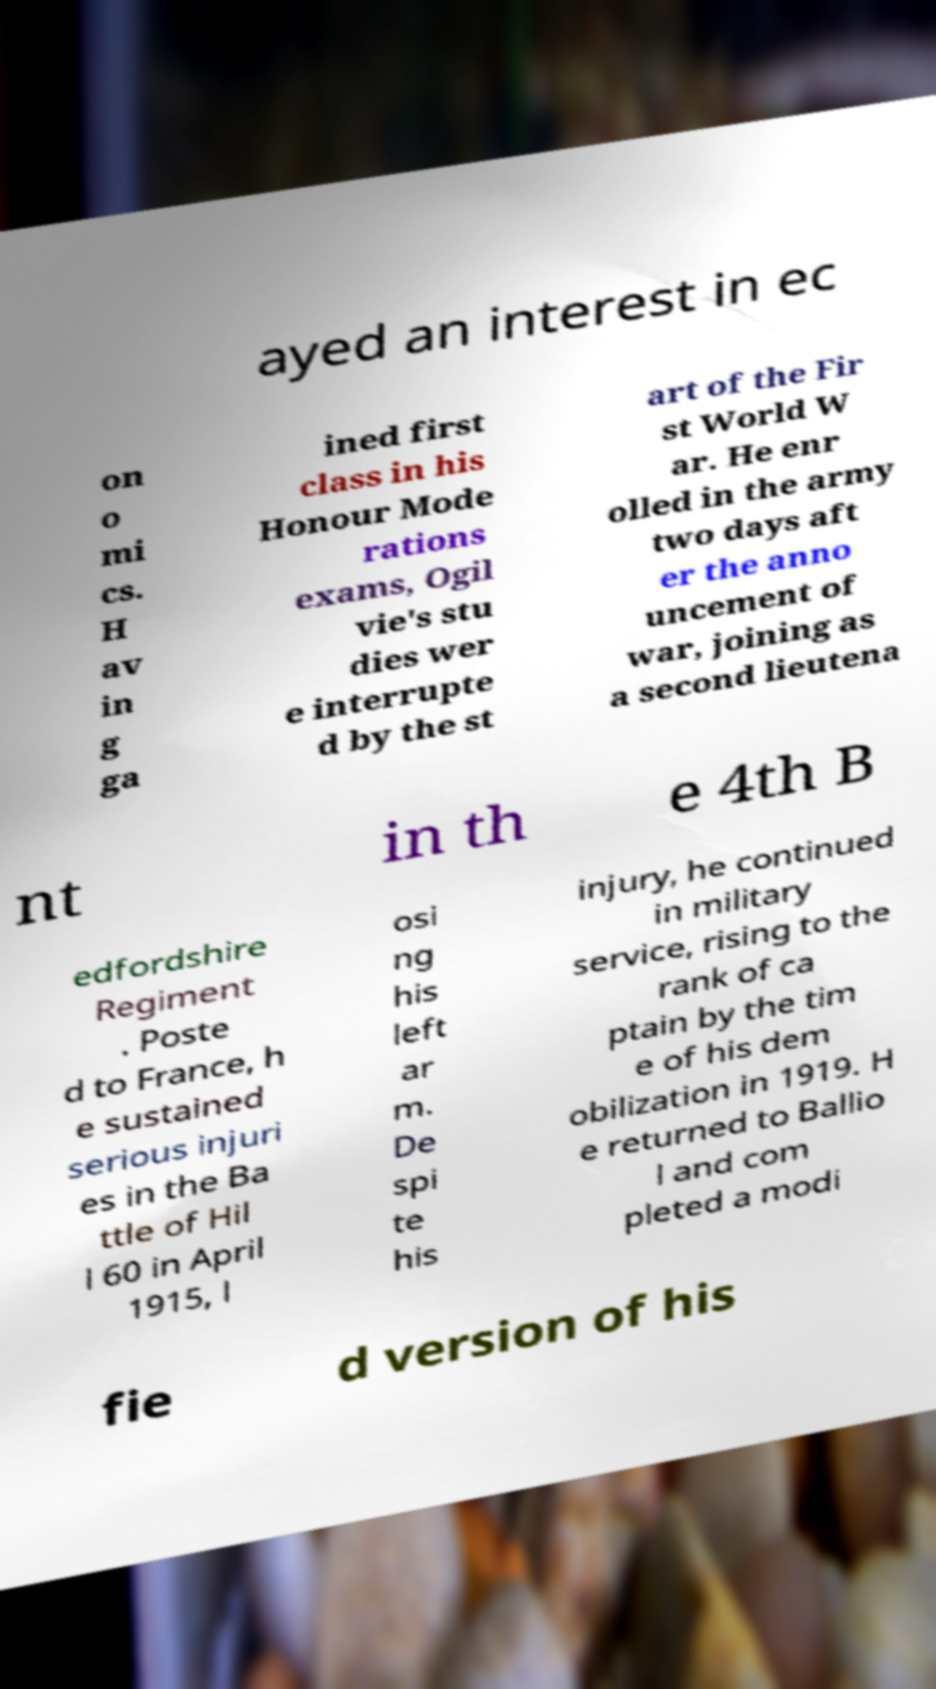Could you extract and type out the text from this image? ayed an interest in ec on o mi cs. H av in g ga ined first class in his Honour Mode rations exams, Ogil vie's stu dies wer e interrupte d by the st art of the Fir st World W ar. He enr olled in the army two days aft er the anno uncement of war, joining as a second lieutena nt in th e 4th B edfordshire Regiment . Poste d to France, h e sustained serious injuri es in the Ba ttle of Hil l 60 in April 1915, l osi ng his left ar m. De spi te his injury, he continued in military service, rising to the rank of ca ptain by the tim e of his dem obilization in 1919. H e returned to Ballio l and com pleted a modi fie d version of his 